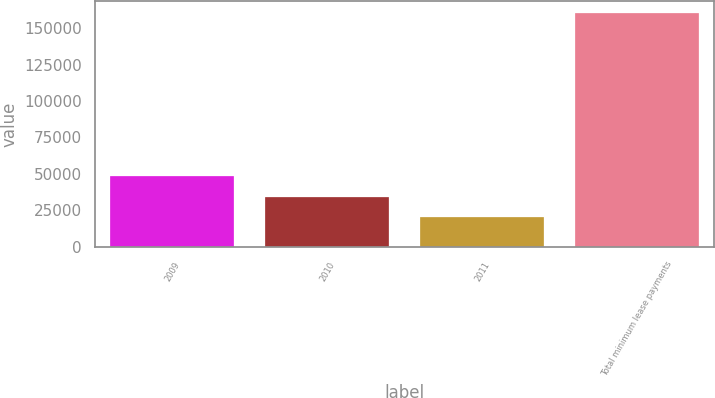Convert chart. <chart><loc_0><loc_0><loc_500><loc_500><bar_chart><fcel>2009<fcel>2010<fcel>2011<fcel>Total minimum lease payments<nl><fcel>48273.8<fcel>34250.9<fcel>20228<fcel>160457<nl></chart> 